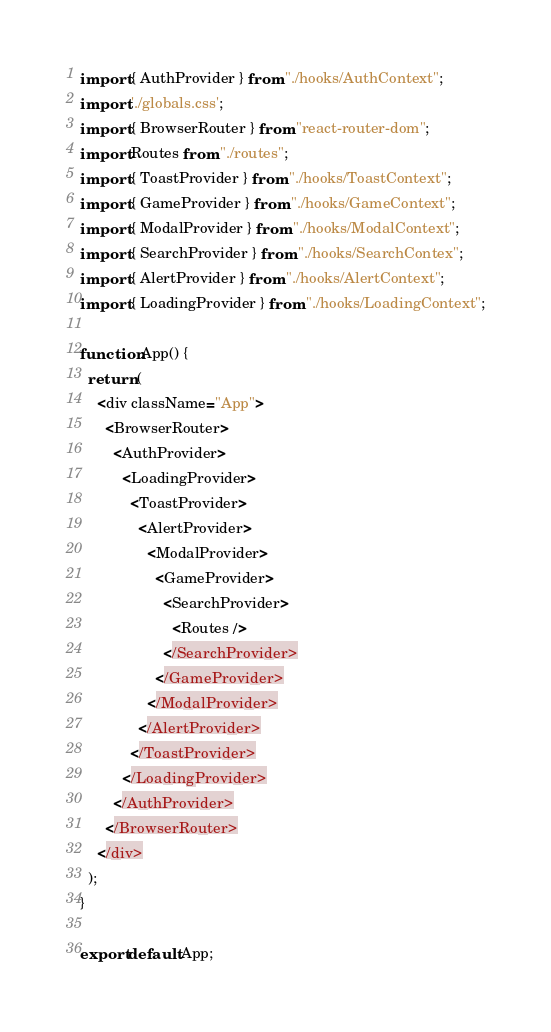<code> <loc_0><loc_0><loc_500><loc_500><_TypeScript_>import { AuthProvider } from "./hooks/AuthContext";
import './globals.css';
import { BrowserRouter } from "react-router-dom";
import Routes from "./routes";
import { ToastProvider } from "./hooks/ToastContext";
import { GameProvider } from "./hooks/GameContext";
import { ModalProvider } from "./hooks/ModalContext";
import { SearchProvider } from "./hooks/SearchContex";
import { AlertProvider } from "./hooks/AlertContext";
import { LoadingProvider } from "./hooks/LoadingContext";

function App() {
  return (
    <div className="App">
      <BrowserRouter>
        <AuthProvider>
          <LoadingProvider>
            <ToastProvider>
              <AlertProvider>
                <ModalProvider>
                  <GameProvider>
                    <SearchProvider>
                      <Routes />
                    </SearchProvider>
                  </GameProvider>
                </ModalProvider>
              </AlertProvider>
            </ToastProvider>
          </LoadingProvider>
        </AuthProvider>
      </BrowserRouter>
    </div>
  );
}

export default App;
</code> 